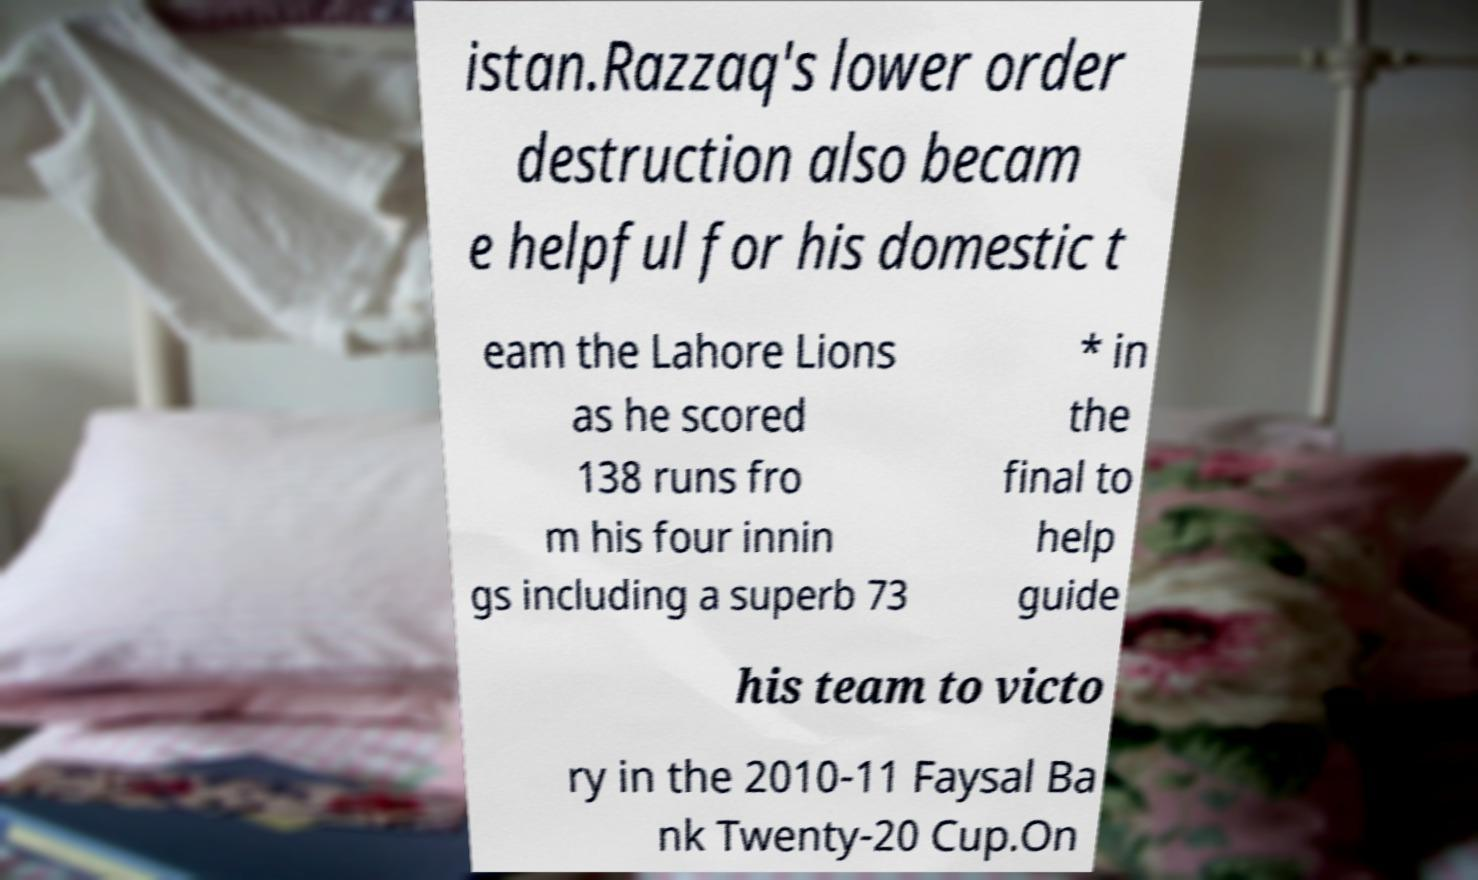There's text embedded in this image that I need extracted. Can you transcribe it verbatim? istan.Razzaq's lower order destruction also becam e helpful for his domestic t eam the Lahore Lions as he scored 138 runs fro m his four innin gs including a superb 73 * in the final to help guide his team to victo ry in the 2010-11 Faysal Ba nk Twenty-20 Cup.On 